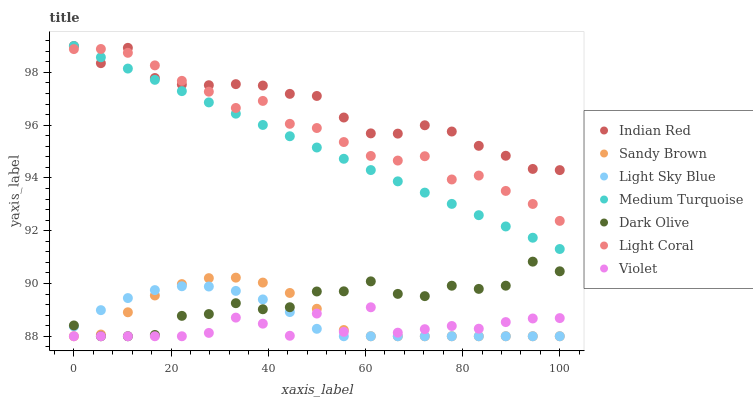Does Violet have the minimum area under the curve?
Answer yes or no. Yes. Does Indian Red have the maximum area under the curve?
Answer yes or no. Yes. Does Dark Olive have the minimum area under the curve?
Answer yes or no. No. Does Dark Olive have the maximum area under the curve?
Answer yes or no. No. Is Medium Turquoise the smoothest?
Answer yes or no. Yes. Is Violet the roughest?
Answer yes or no. Yes. Is Dark Olive the smoothest?
Answer yes or no. No. Is Dark Olive the roughest?
Answer yes or no. No. Does Dark Olive have the lowest value?
Answer yes or no. Yes. Does Light Coral have the lowest value?
Answer yes or no. No. Does Medium Turquoise have the highest value?
Answer yes or no. Yes. Does Dark Olive have the highest value?
Answer yes or no. No. Is Violet less than Light Coral?
Answer yes or no. Yes. Is Light Coral greater than Light Sky Blue?
Answer yes or no. Yes. Does Indian Red intersect Medium Turquoise?
Answer yes or no. Yes. Is Indian Red less than Medium Turquoise?
Answer yes or no. No. Is Indian Red greater than Medium Turquoise?
Answer yes or no. No. Does Violet intersect Light Coral?
Answer yes or no. No. 